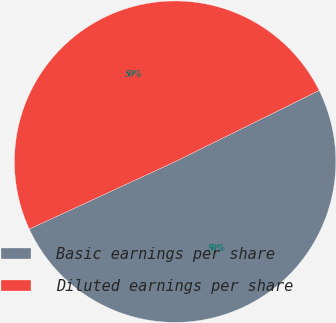Convert chart to OTSL. <chart><loc_0><loc_0><loc_500><loc_500><pie_chart><fcel>Basic earnings per share<fcel>Diluted earnings per share<nl><fcel>50.42%<fcel>49.58%<nl></chart> 